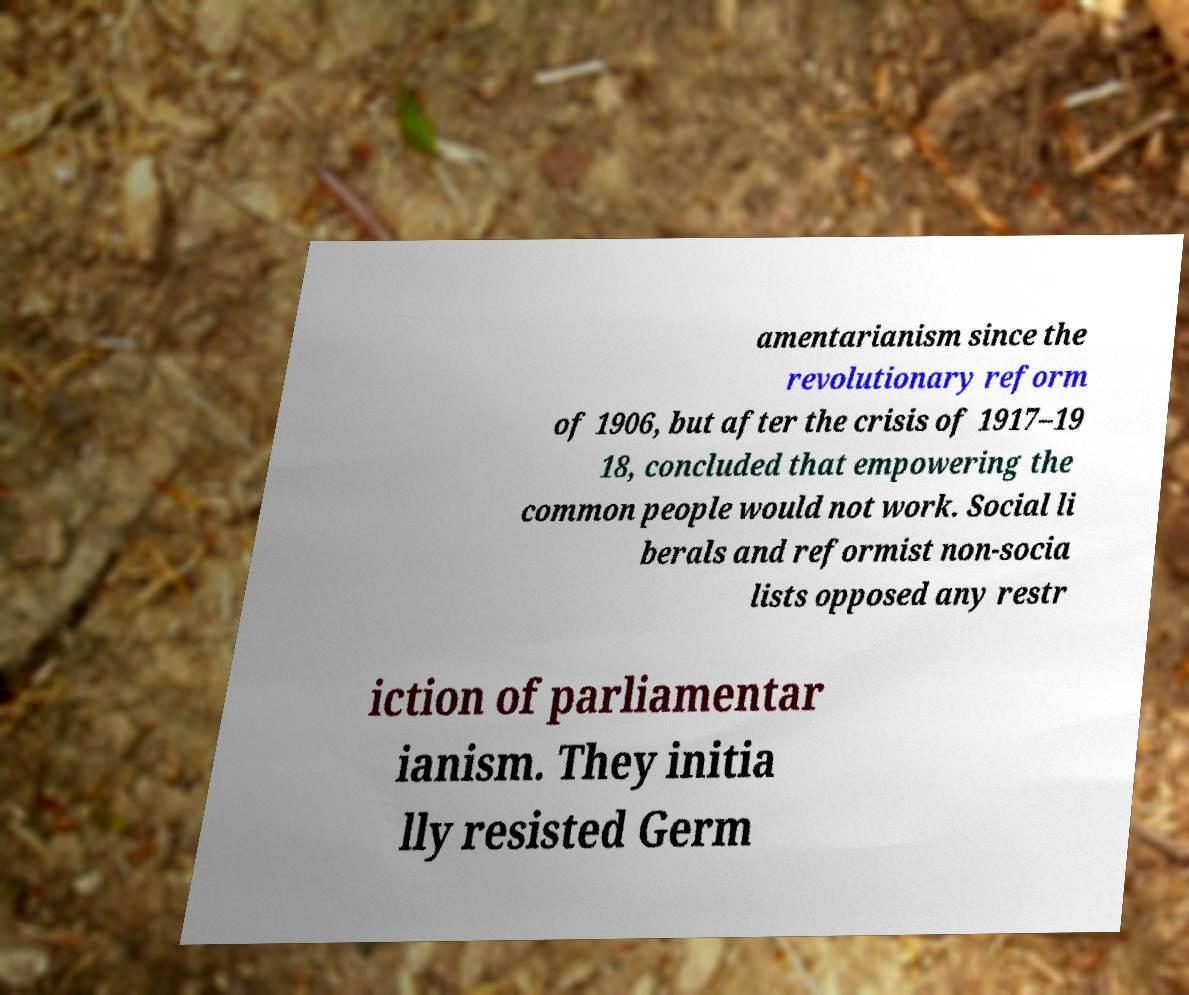Please identify and transcribe the text found in this image. amentarianism since the revolutionary reform of 1906, but after the crisis of 1917–19 18, concluded that empowering the common people would not work. Social li berals and reformist non-socia lists opposed any restr iction of parliamentar ianism. They initia lly resisted Germ 